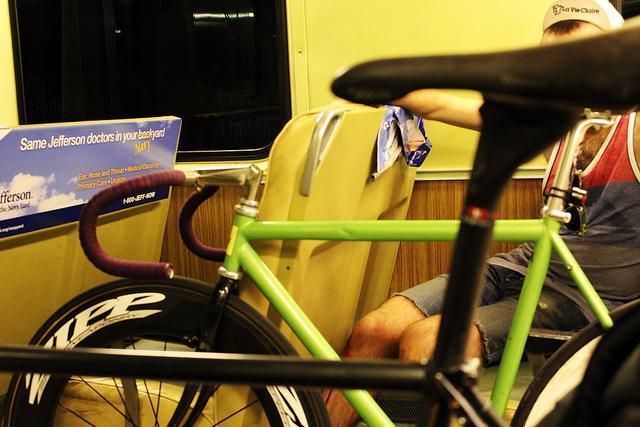How many green bikes are there?
Give a very brief answer. 1. How many chairs are there?
Give a very brief answer. 1. How many bicycles are in the photo?
Give a very brief answer. 2. How many bears are licking their paws?
Give a very brief answer. 0. 